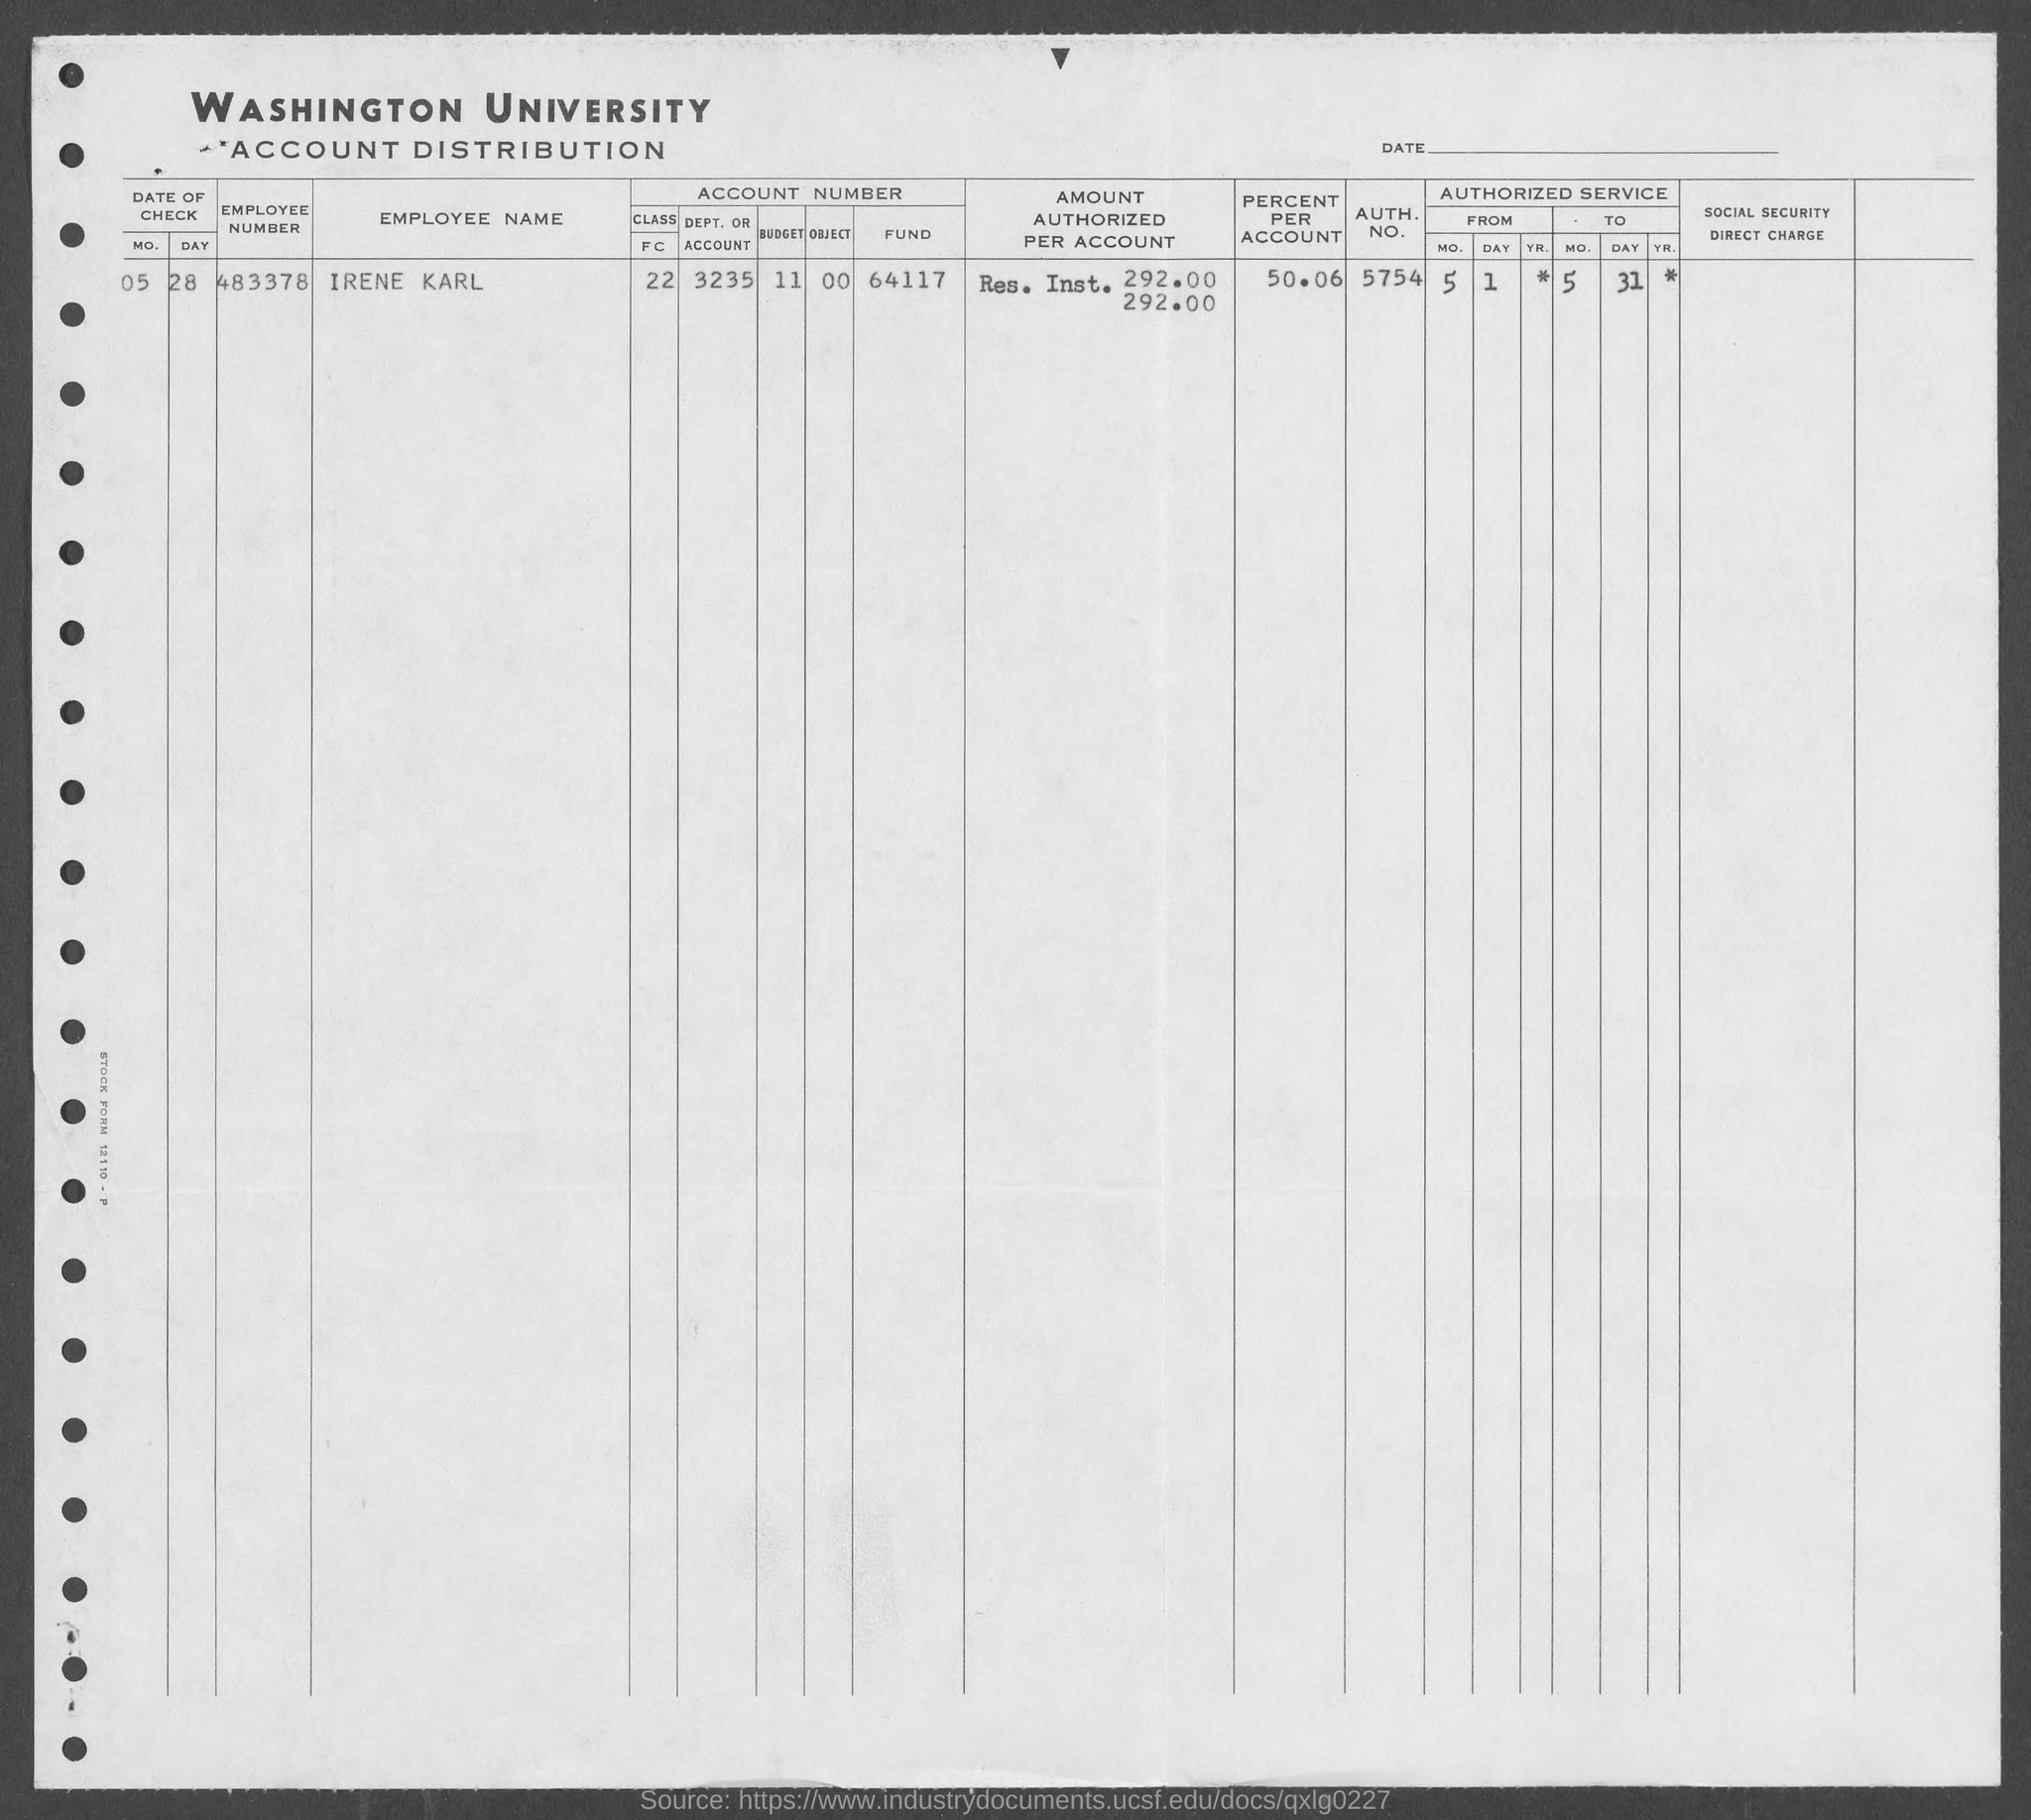What is the employee number of irene karl?
Make the answer very short. 483378. What is the auth. no. of irene karl ?
Offer a very short reply. 5754. What is the percent per account of irene karl?
Ensure brevity in your answer.  50.06%. 